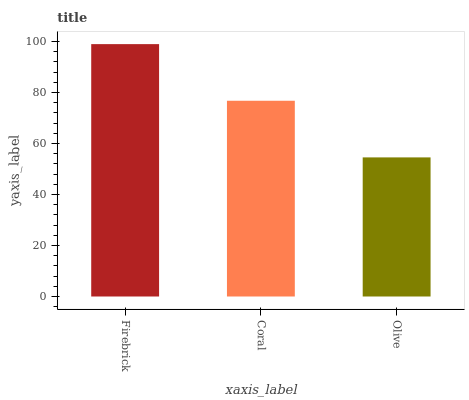Is Coral the minimum?
Answer yes or no. No. Is Coral the maximum?
Answer yes or no. No. Is Firebrick greater than Coral?
Answer yes or no. Yes. Is Coral less than Firebrick?
Answer yes or no. Yes. Is Coral greater than Firebrick?
Answer yes or no. No. Is Firebrick less than Coral?
Answer yes or no. No. Is Coral the high median?
Answer yes or no. Yes. Is Coral the low median?
Answer yes or no. Yes. Is Firebrick the high median?
Answer yes or no. No. Is Firebrick the low median?
Answer yes or no. No. 